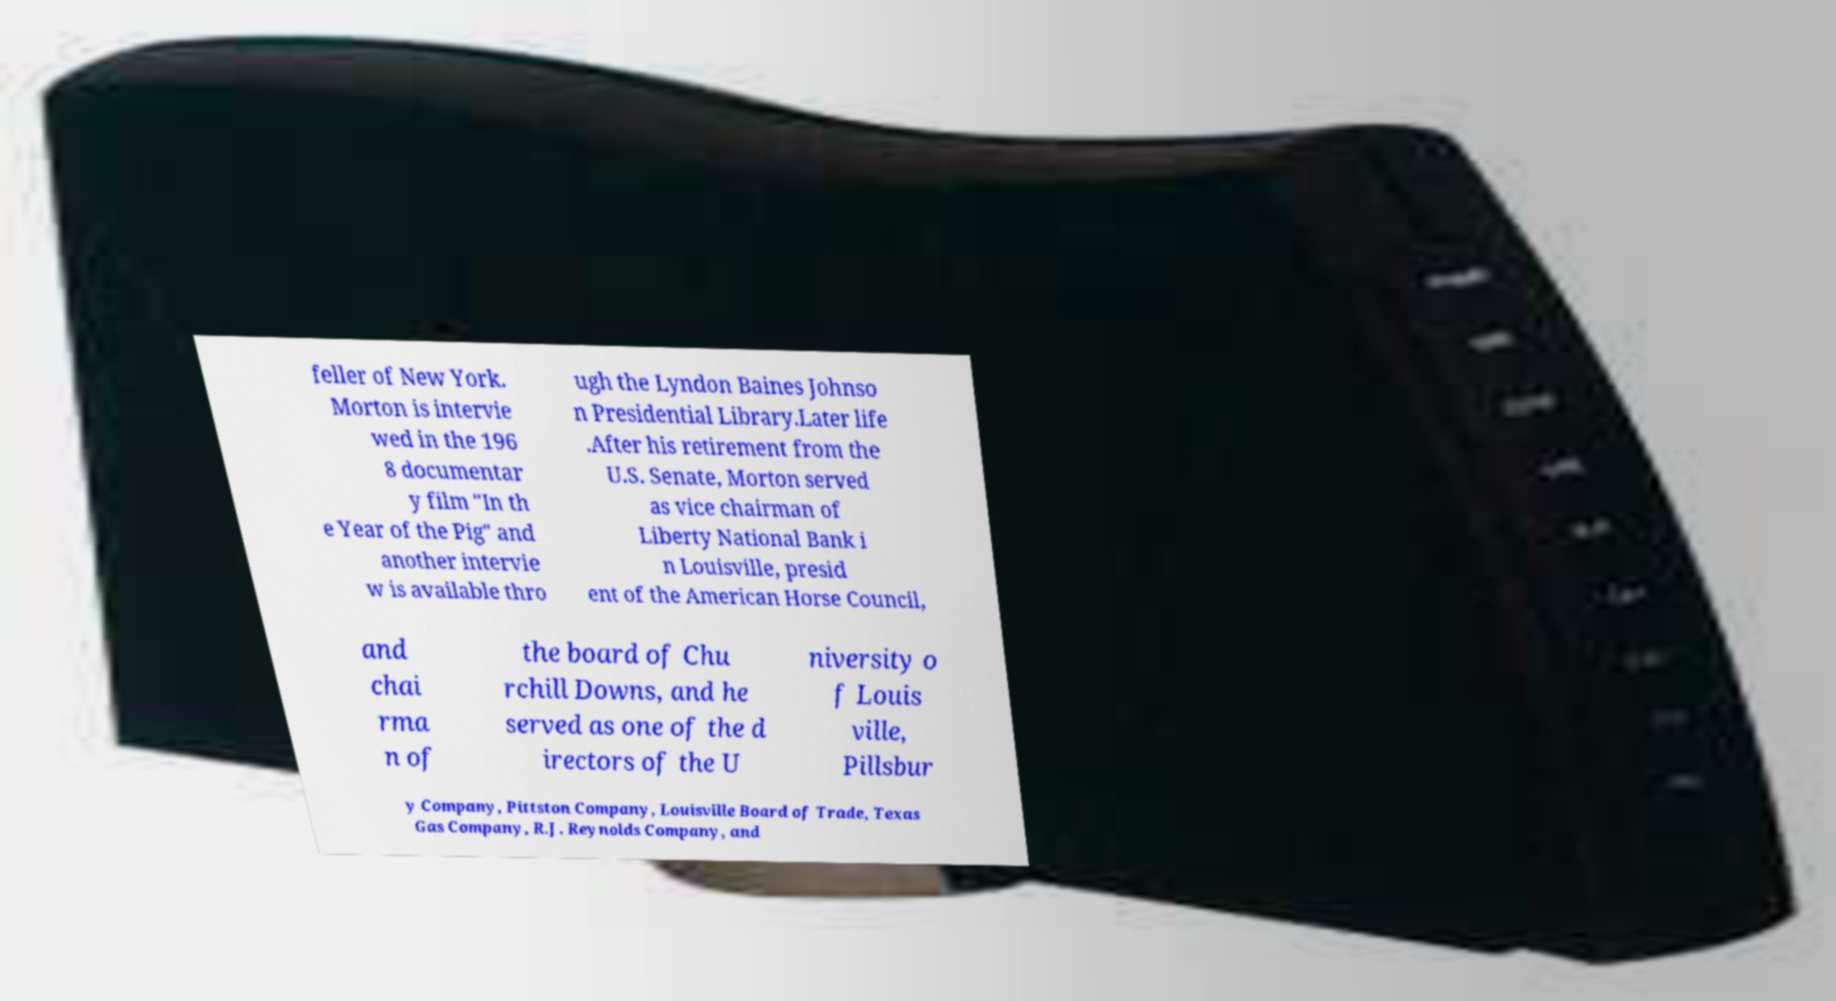Could you assist in decoding the text presented in this image and type it out clearly? feller of New York. Morton is intervie wed in the 196 8 documentar y film "In th e Year of the Pig" and another intervie w is available thro ugh the Lyndon Baines Johnso n Presidential Library.Later life .After his retirement from the U.S. Senate, Morton served as vice chairman of Liberty National Bank i n Louisville, presid ent of the American Horse Council, and chai rma n of the board of Chu rchill Downs, and he served as one of the d irectors of the U niversity o f Louis ville, Pillsbur y Company, Pittston Company, Louisville Board of Trade, Texas Gas Company, R.J. Reynolds Company, and 